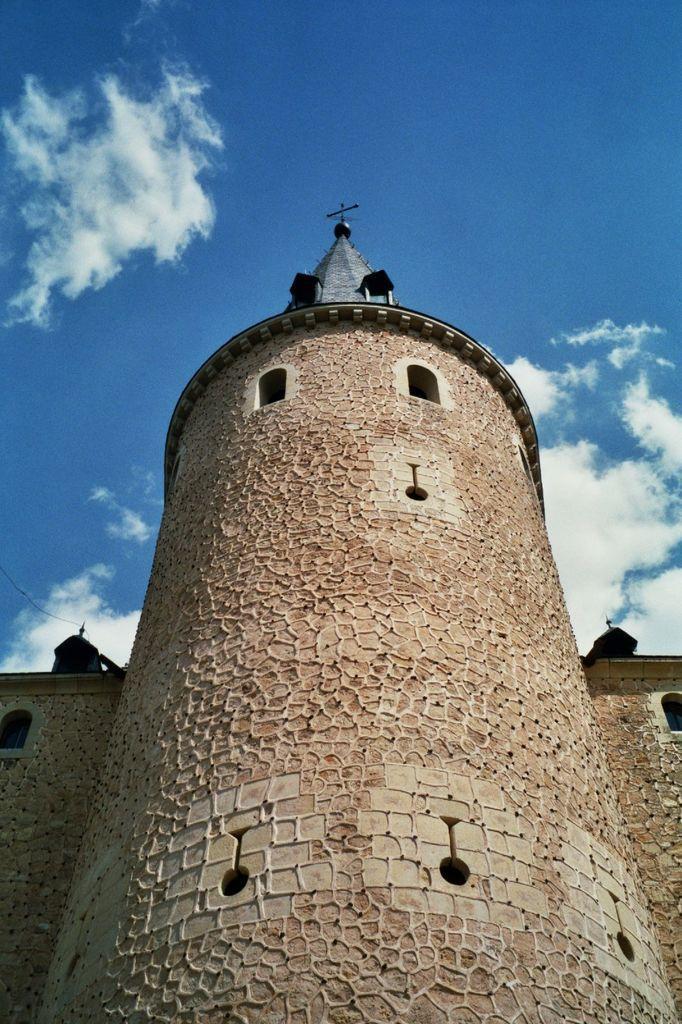Please provide a concise description of this image. In this picture I can see in the middle it looks like a fort, at the top there is the sky. 